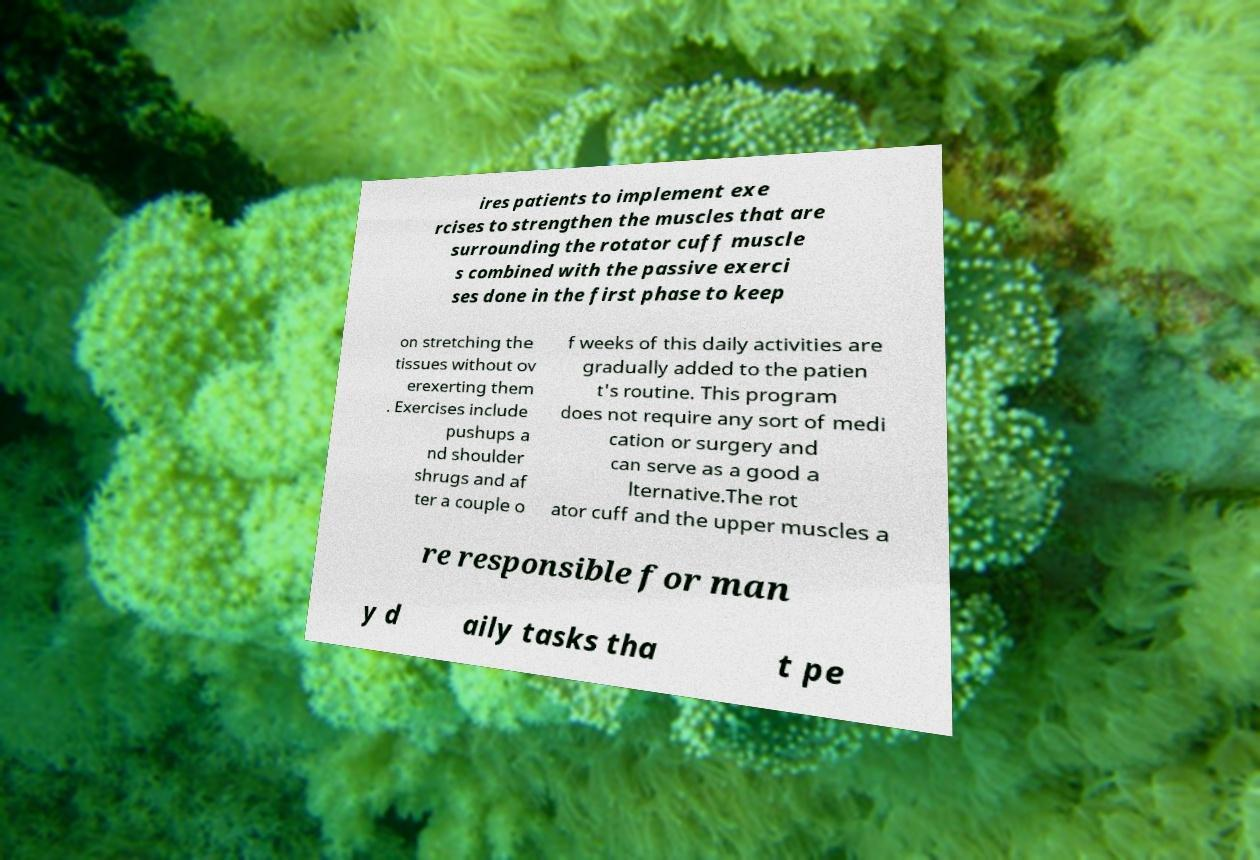Please read and relay the text visible in this image. What does it say? ires patients to implement exe rcises to strengthen the muscles that are surrounding the rotator cuff muscle s combined with the passive exerci ses done in the first phase to keep on stretching the tissues without ov erexerting them . Exercises include pushups a nd shoulder shrugs and af ter a couple o f weeks of this daily activities are gradually added to the patien t's routine. This program does not require any sort of medi cation or surgery and can serve as a good a lternative.The rot ator cuff and the upper muscles a re responsible for man y d aily tasks tha t pe 